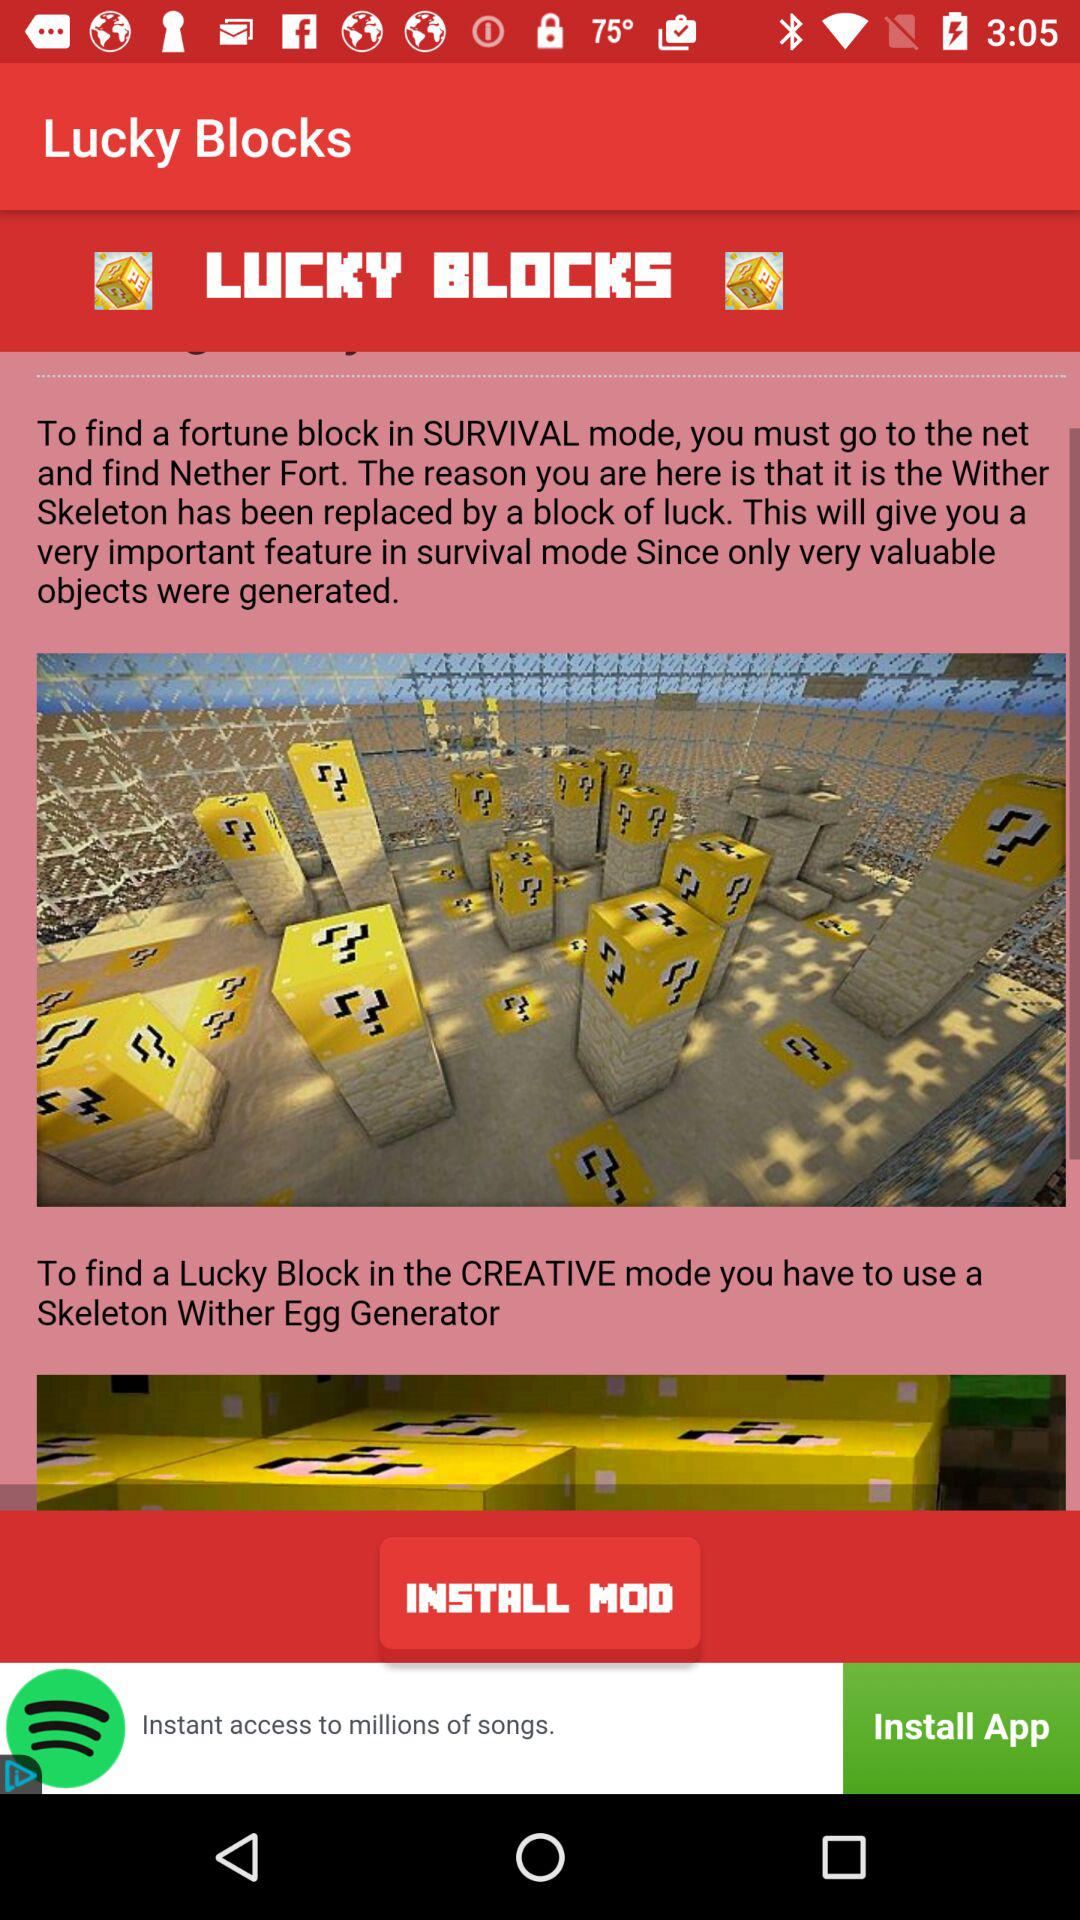What is the application name? The application name is "Lucky Blocks". 